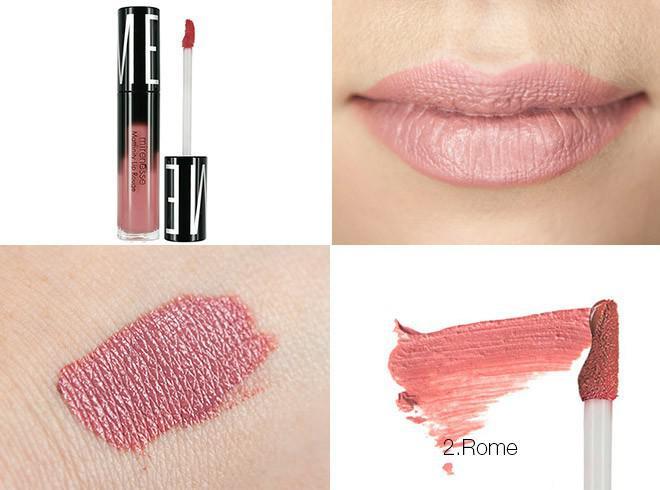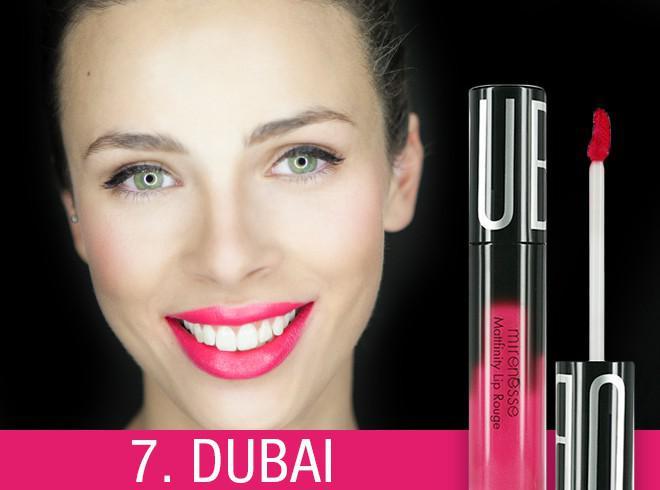The first image is the image on the left, the second image is the image on the right. Considering the images on both sides, is "Right image shows a model's face on black next to a lipstick brush and tube." valid? Answer yes or no. Yes. The first image is the image on the left, the second image is the image on the right. Examine the images to the left and right. Is the description "One image shows lipstick on skin that is not lips." accurate? Answer yes or no. Yes. 